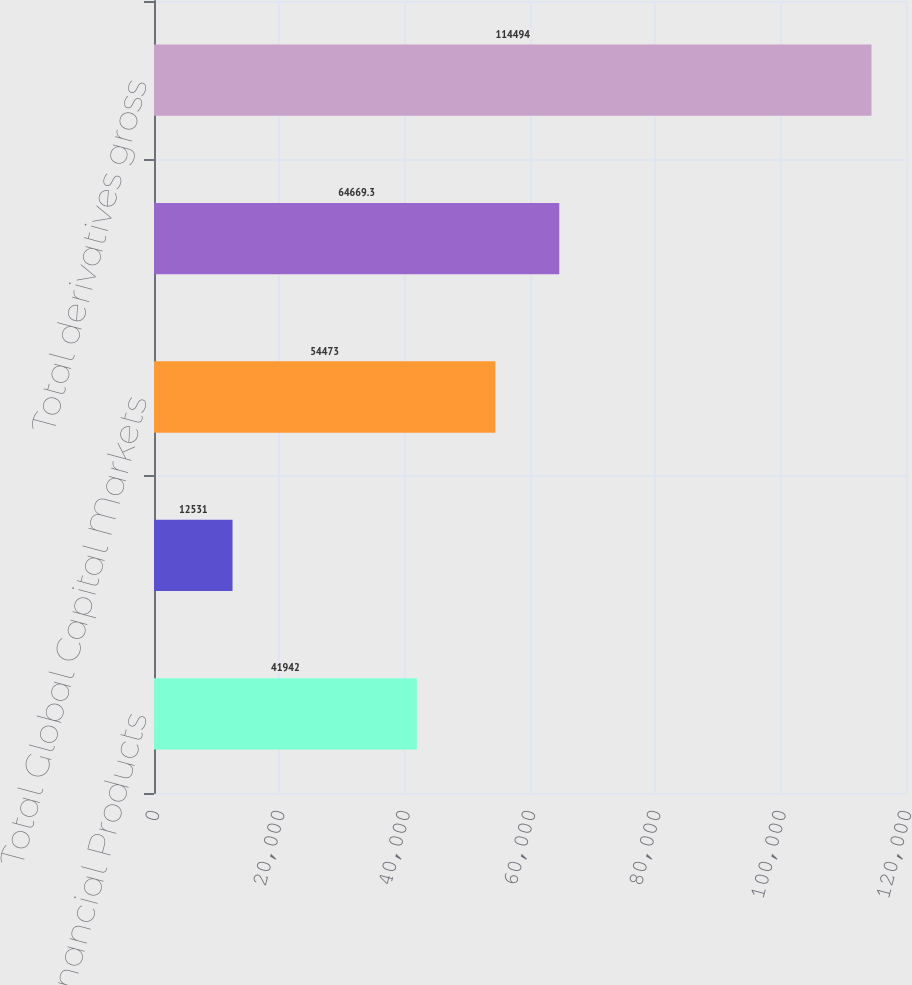<chart> <loc_0><loc_0><loc_500><loc_500><bar_chart><fcel>AIG Financial Products<fcel>AIG Markets<fcel>Total Global Capital Markets<fcel>Non-Global Capital Markets<fcel>Total derivatives gross<nl><fcel>41942<fcel>12531<fcel>54473<fcel>64669.3<fcel>114494<nl></chart> 